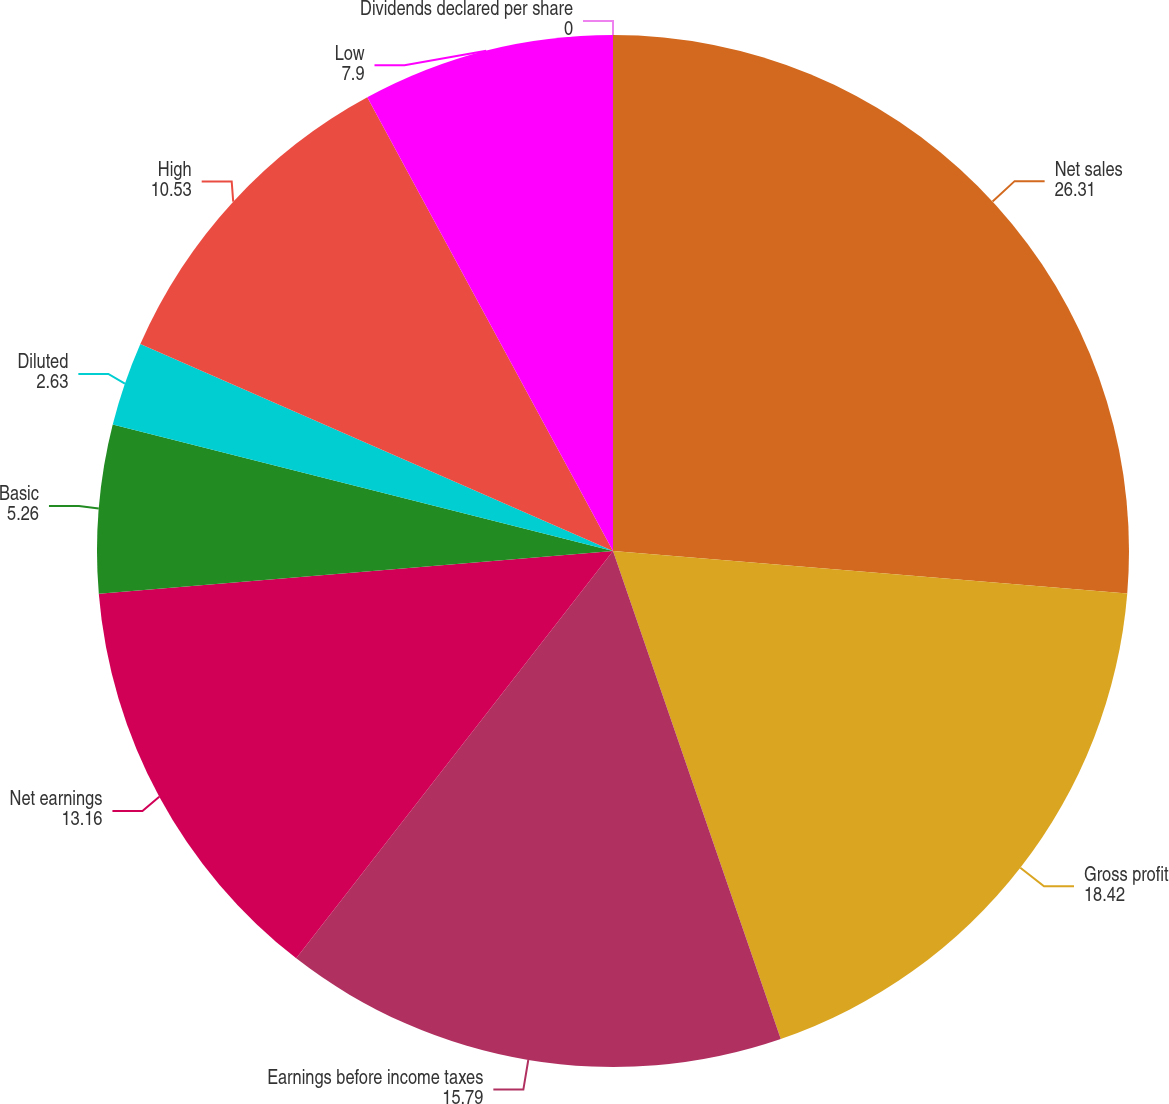Convert chart. <chart><loc_0><loc_0><loc_500><loc_500><pie_chart><fcel>Net sales<fcel>Gross profit<fcel>Earnings before income taxes<fcel>Net earnings<fcel>Basic<fcel>Diluted<fcel>High<fcel>Low<fcel>Dividends declared per share<nl><fcel>26.31%<fcel>18.42%<fcel>15.79%<fcel>13.16%<fcel>5.26%<fcel>2.63%<fcel>10.53%<fcel>7.9%<fcel>0.0%<nl></chart> 